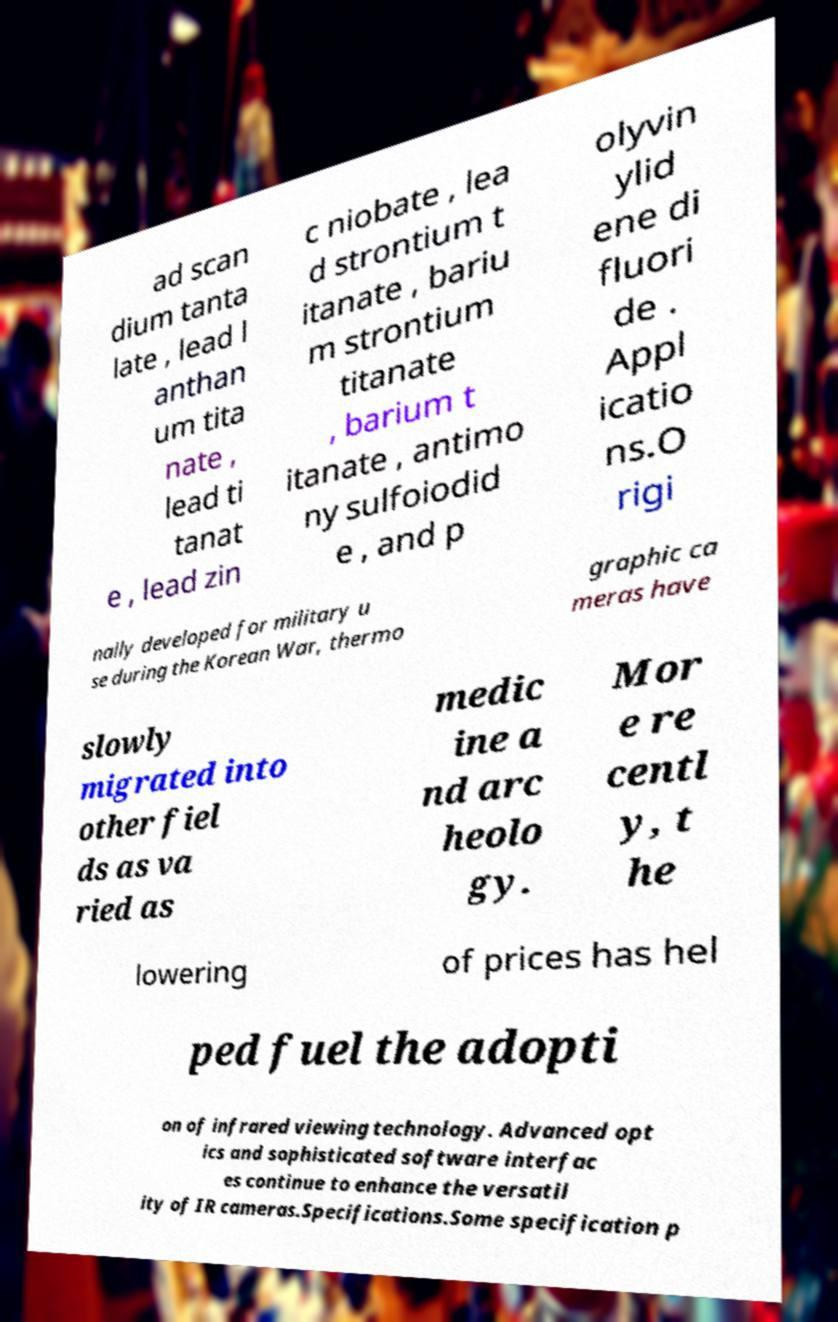For documentation purposes, I need the text within this image transcribed. Could you provide that? ad scan dium tanta late , lead l anthan um tita nate , lead ti tanat e , lead zin c niobate , lea d strontium t itanate , bariu m strontium titanate , barium t itanate , antimo ny sulfoiodid e , and p olyvin ylid ene di fluori de . Appl icatio ns.O rigi nally developed for military u se during the Korean War, thermo graphic ca meras have slowly migrated into other fiel ds as va ried as medic ine a nd arc heolo gy. Mor e re centl y, t he lowering of prices has hel ped fuel the adopti on of infrared viewing technology. Advanced opt ics and sophisticated software interfac es continue to enhance the versatil ity of IR cameras.Specifications.Some specification p 